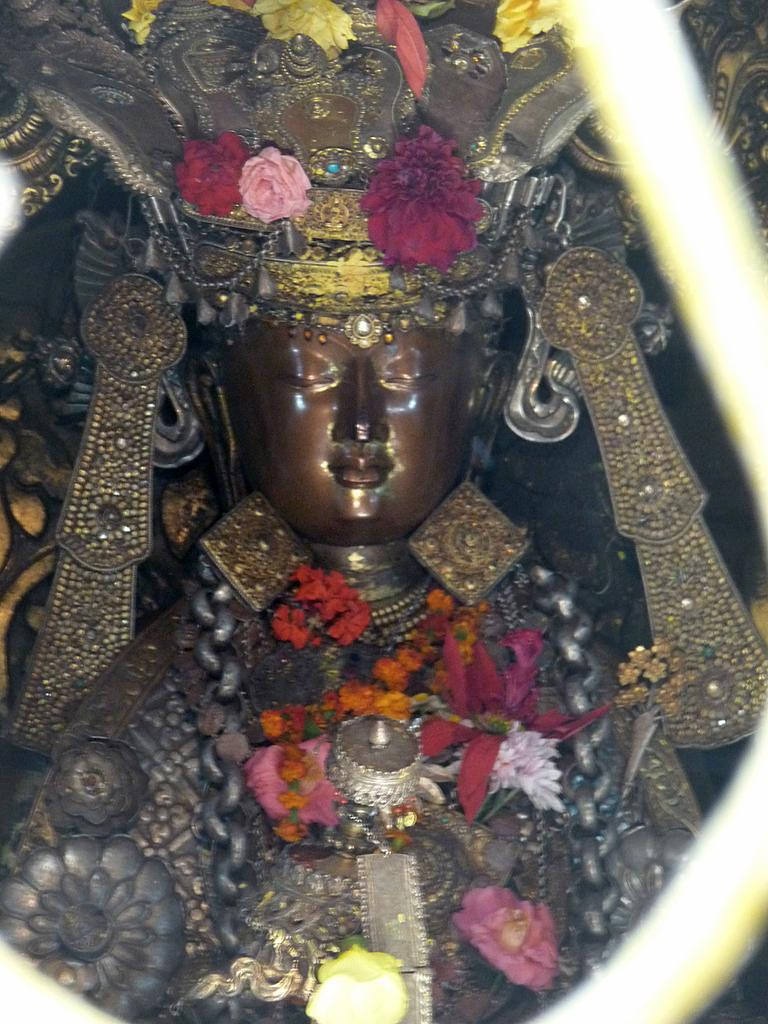What is the main subject of the image? There is a sculpture in the image. What decorative elements are present on the sculpture? The sculpture has flowers on it. What colors can be seen in the flowers? The flowers have pink, white, red, and yellow colors. Where is the faucet located in the image? There is no faucet present in the image. What type of waste is being disposed of in the image? There is no waste present in the image. 